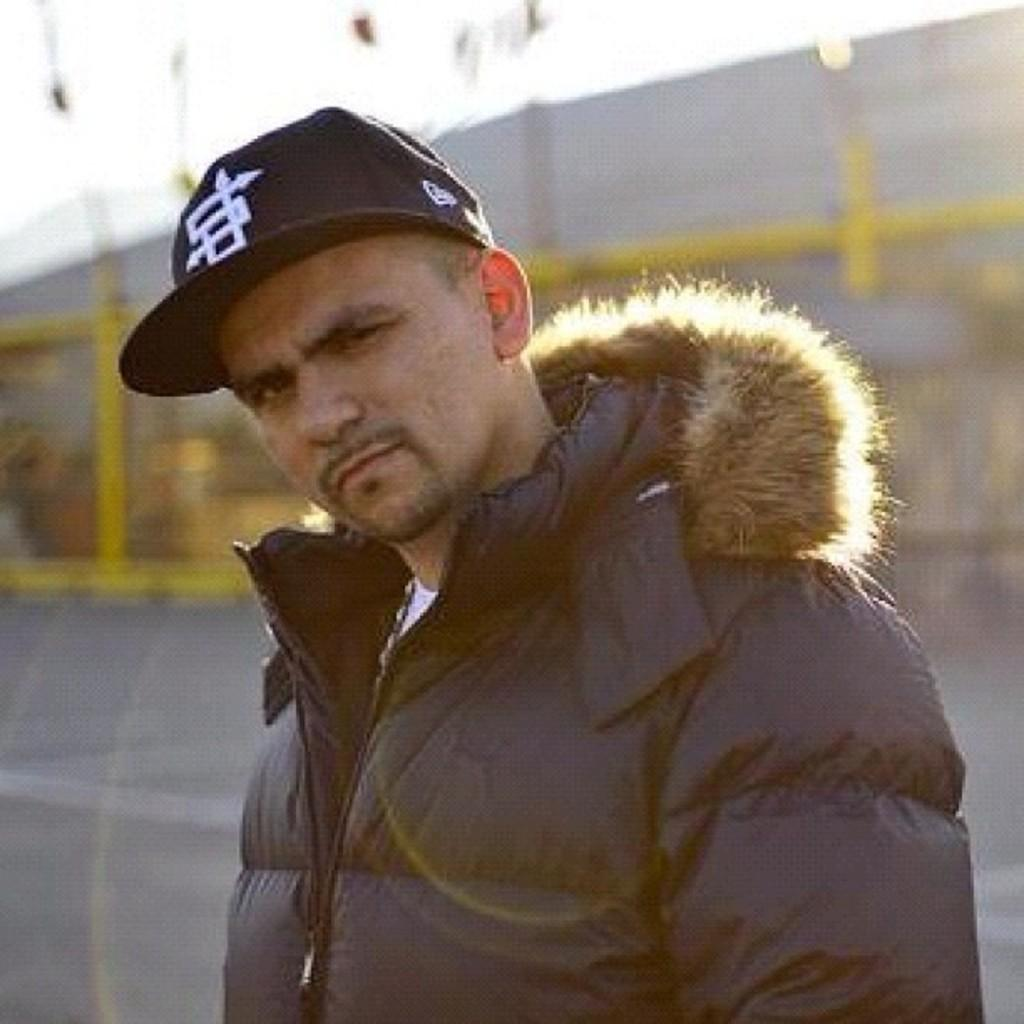Who is present in the image? There is a man in the image. Where is the man located in the image? The man is located towards the bottom of the image. What is the man wearing on his head? The man is wearing a cap. What is behind the man in the image? There is a fencing behind the man. What other structure can be seen in the image? There is a wall in the image. What part of the natural environment is visible in the image? The sky is visible towards the top of the image. What type of produce can be seen growing on the wall in the image? There is no produce visible on the wall in the image. What sound does the horn make in the image? There is no horn present in the image. 